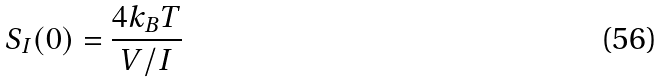Convert formula to latex. <formula><loc_0><loc_0><loc_500><loc_500>S _ { I } ( 0 ) = \frac { 4 k _ { B } T } { V / I }</formula> 